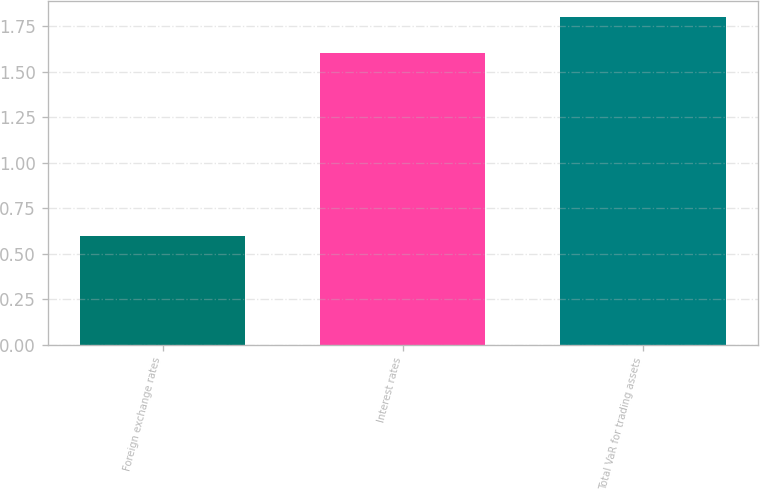Convert chart. <chart><loc_0><loc_0><loc_500><loc_500><bar_chart><fcel>Foreign exchange rates<fcel>Interest rates<fcel>Total VaR for trading assets<nl><fcel>0.6<fcel>1.6<fcel>1.8<nl></chart> 